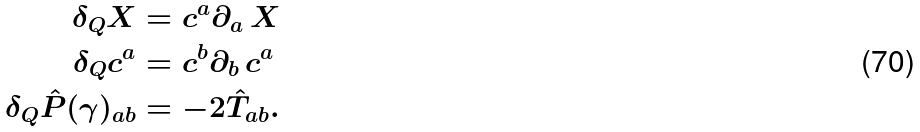<formula> <loc_0><loc_0><loc_500><loc_500>\delta _ { Q } X & = c ^ { a } \partial _ { a } \, X \\ \delta _ { Q } c ^ { a } & = c ^ { b } \partial _ { b } \, c ^ { a } \\ \delta _ { Q } \hat { P } ( \gamma ) _ { a b } & = - 2 \hat { T } _ { a b } .</formula> 